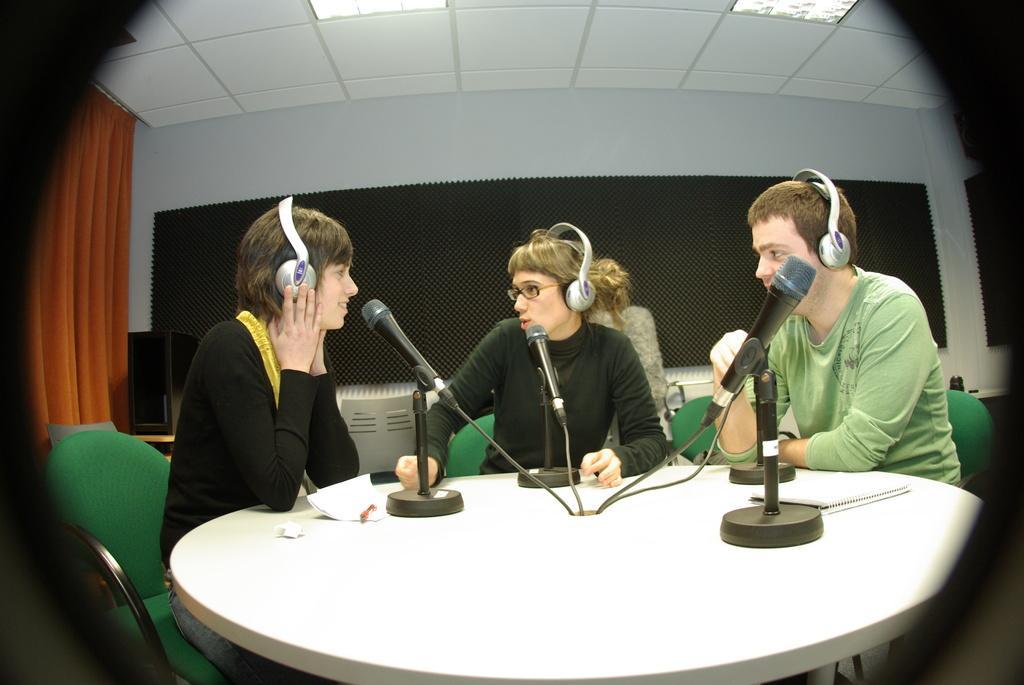Can you describe this image briefly? In this image I can see 2 women and a man and all of them are sitting on the chairs and I can also see there are mics in front of them and there is also a table. In the background I can see a woman, a curtain, the wall and 2 lights over here. 